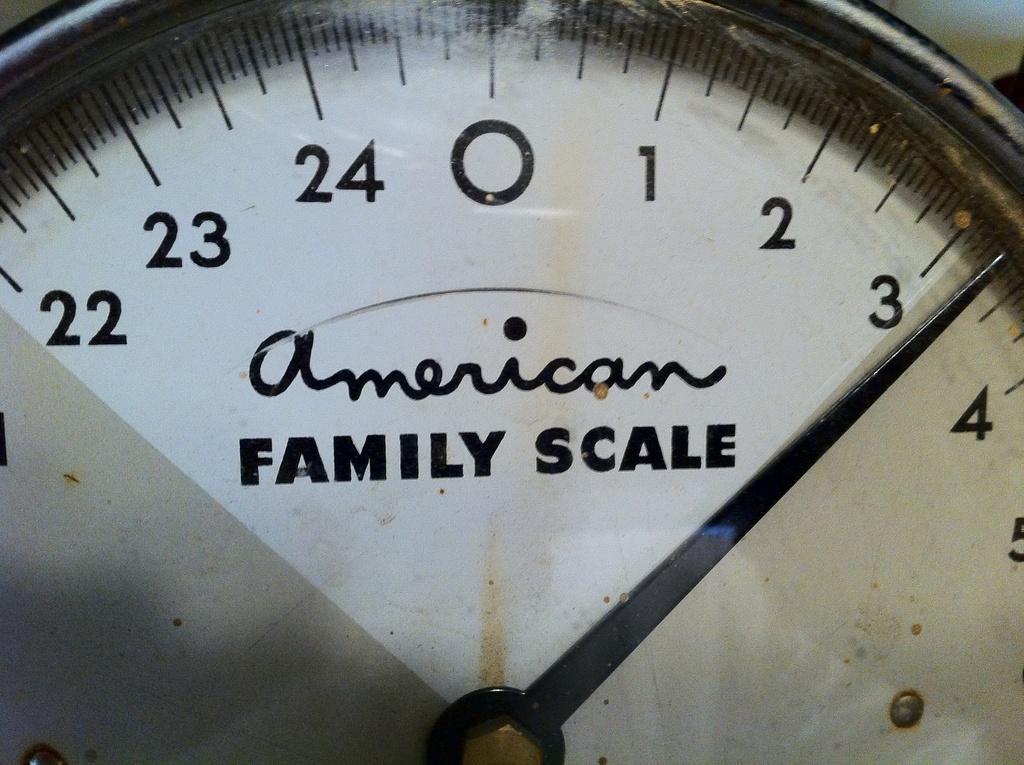How would you summarize this image in a sentence or two? It is an indicator in white color. 